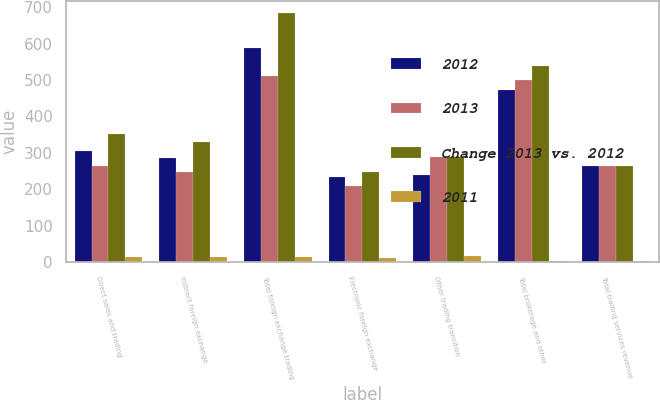<chart> <loc_0><loc_0><loc_500><loc_500><stacked_bar_chart><ecel><fcel>Direct sales and trading<fcel>Indirect foreign exchange<fcel>Total foreign exchange trading<fcel>Electronic foreign exchange<fcel>Other trading transition<fcel>Total brokerage and other<fcel>Total trading services revenue<nl><fcel>2012<fcel>304<fcel>285<fcel>589<fcel>233<fcel>239<fcel>472<fcel>263<nl><fcel>2013<fcel>263<fcel>248<fcel>511<fcel>210<fcel>289<fcel>499<fcel>263<nl><fcel>Change 2013 vs. 2012<fcel>352<fcel>331<fcel>683<fcel>249<fcel>288<fcel>537<fcel>263<nl><fcel>2011<fcel>16<fcel>15<fcel>15<fcel>11<fcel>17<fcel>5<fcel>5<nl></chart> 